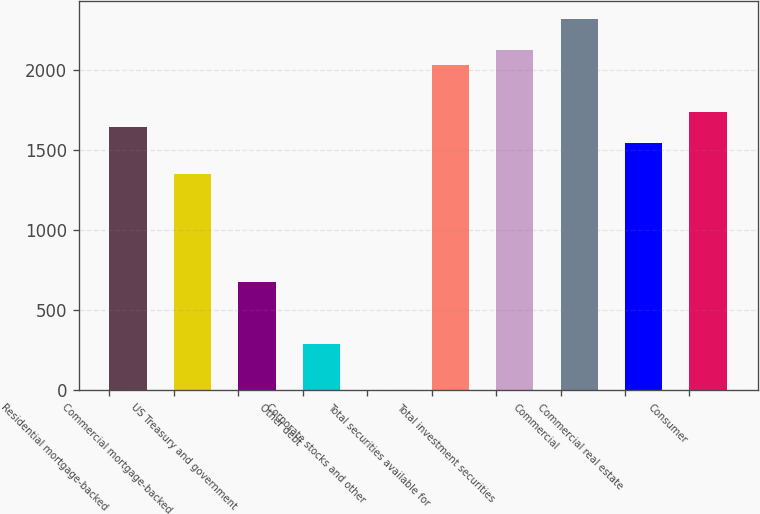<chart> <loc_0><loc_0><loc_500><loc_500><bar_chart><fcel>Residential mortgage-backed<fcel>Commercial mortgage-backed<fcel>US Treasury and government<fcel>Other debt<fcel>Corporate stocks and other<fcel>Total securities available for<fcel>Total investment securities<fcel>Commercial<fcel>Commercial real estate<fcel>Consumer<nl><fcel>1641.5<fcel>1352<fcel>676.5<fcel>290.5<fcel>1<fcel>2027.5<fcel>2124<fcel>2317<fcel>1545<fcel>1738<nl></chart> 